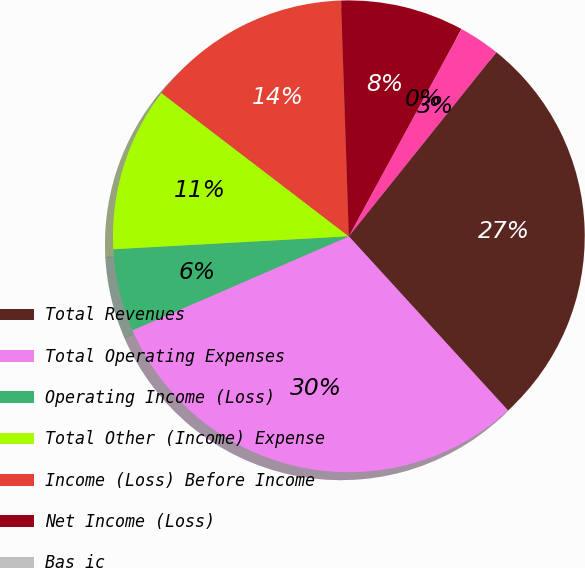Convert chart to OTSL. <chart><loc_0><loc_0><loc_500><loc_500><pie_chart><fcel>Total Revenues<fcel>Total Operating Expenses<fcel>Operating Income (Loss)<fcel>Total Other (Income) Expense<fcel>Income (Loss) Before Income<fcel>Net Income (Loss)<fcel>Bas ic<fcel>Diluted<nl><fcel>27.46%<fcel>30.27%<fcel>5.64%<fcel>11.27%<fcel>14.08%<fcel>8.45%<fcel>0.01%<fcel>2.82%<nl></chart> 